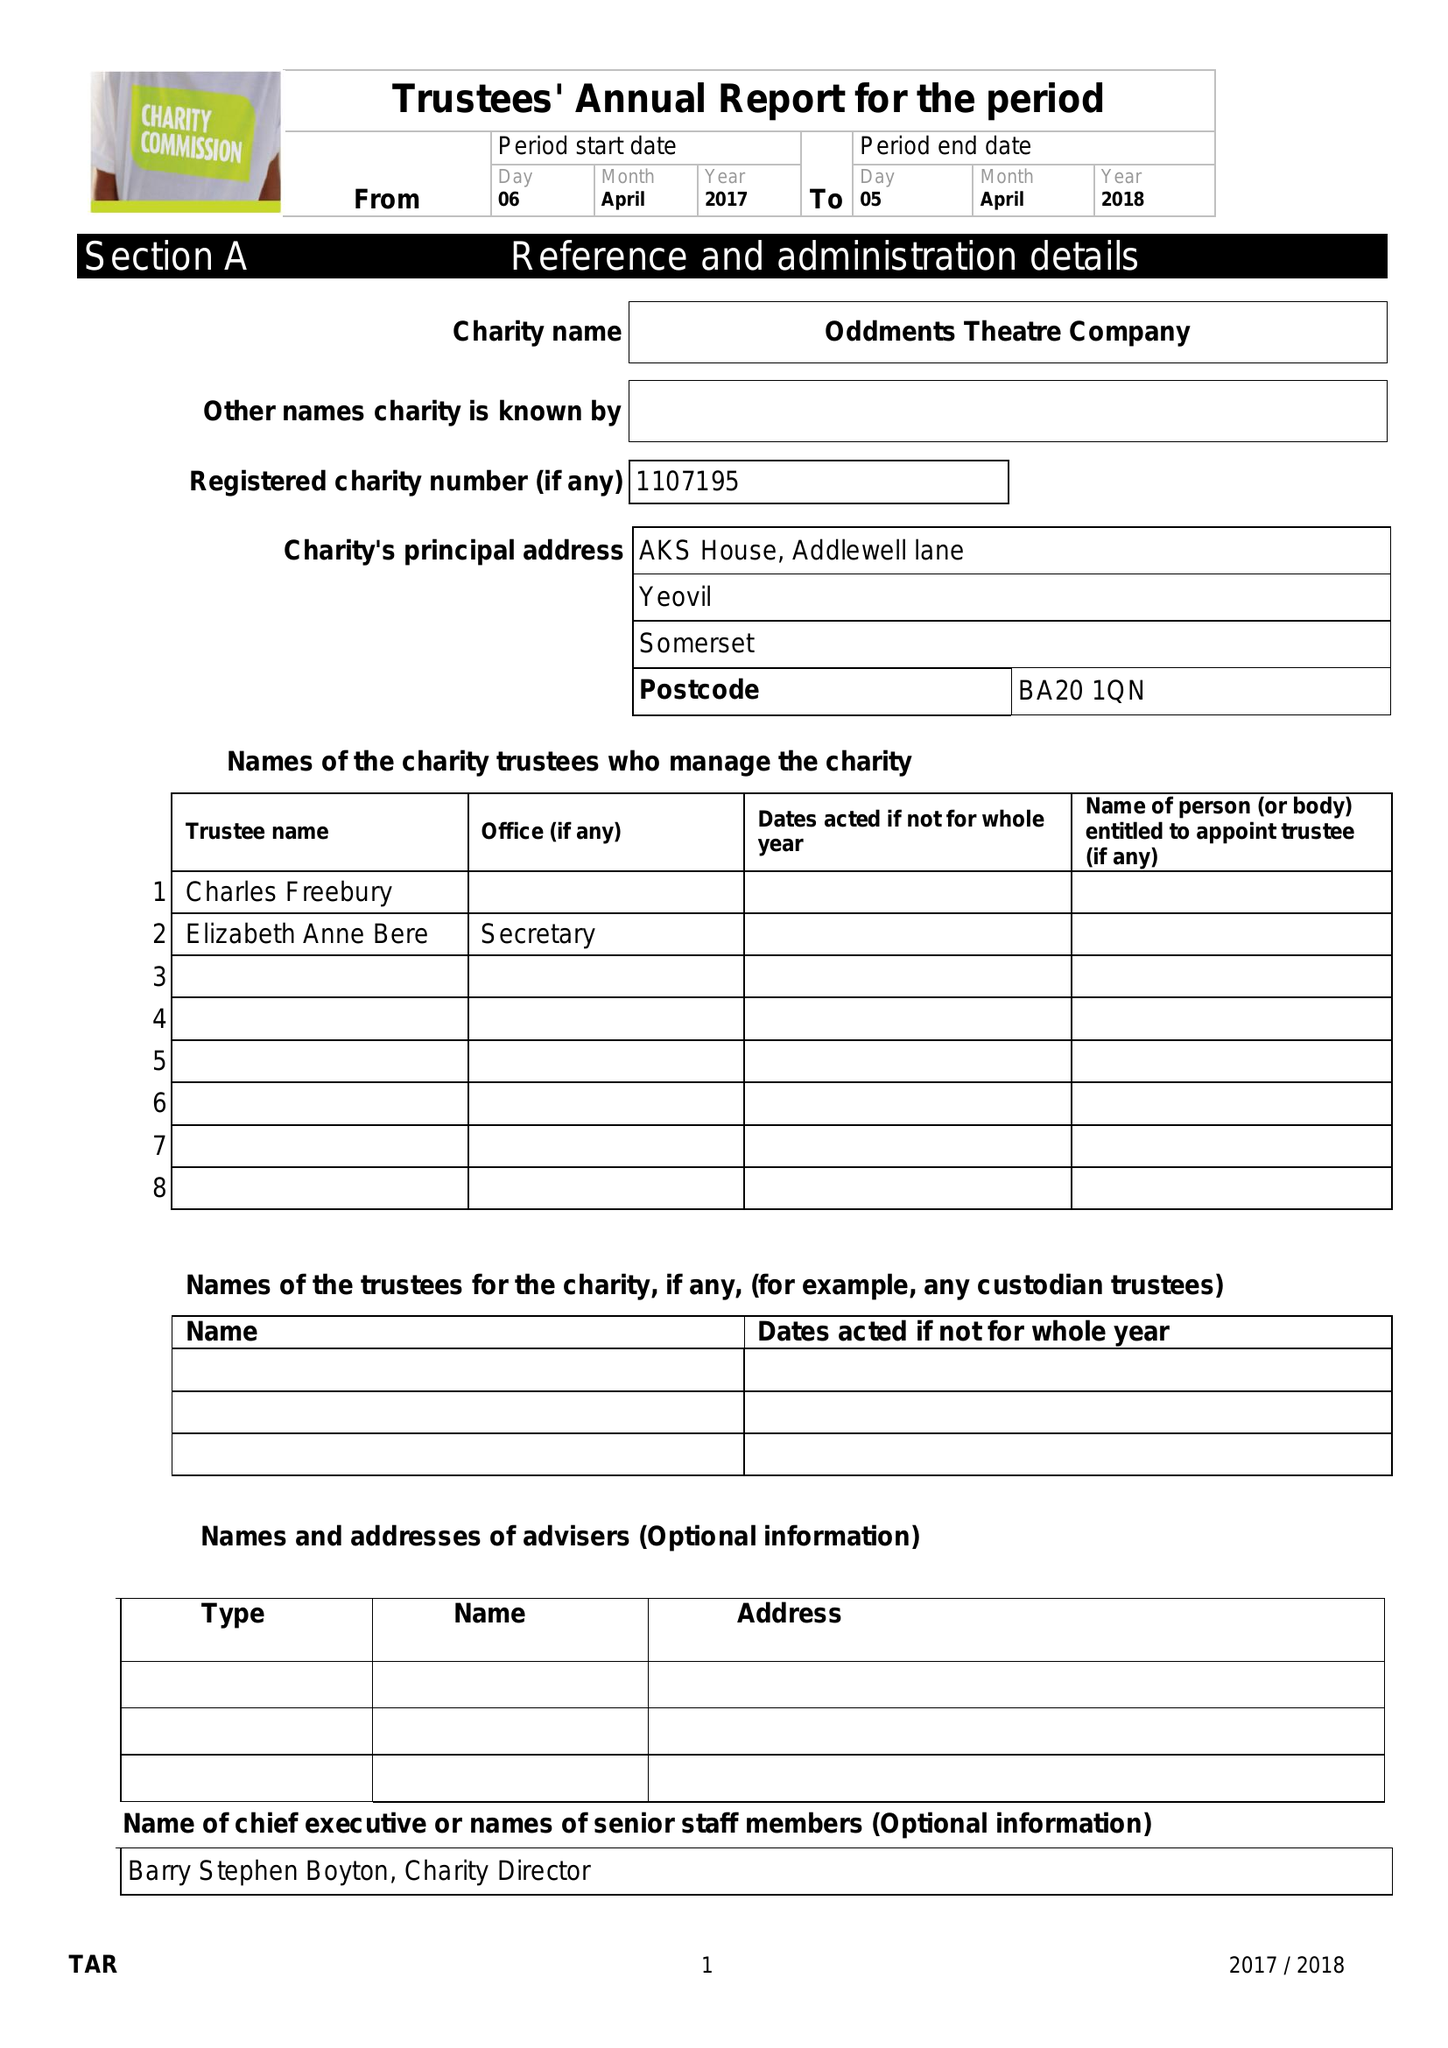What is the value for the income_annually_in_british_pounds?
Answer the question using a single word or phrase. 126257.00 